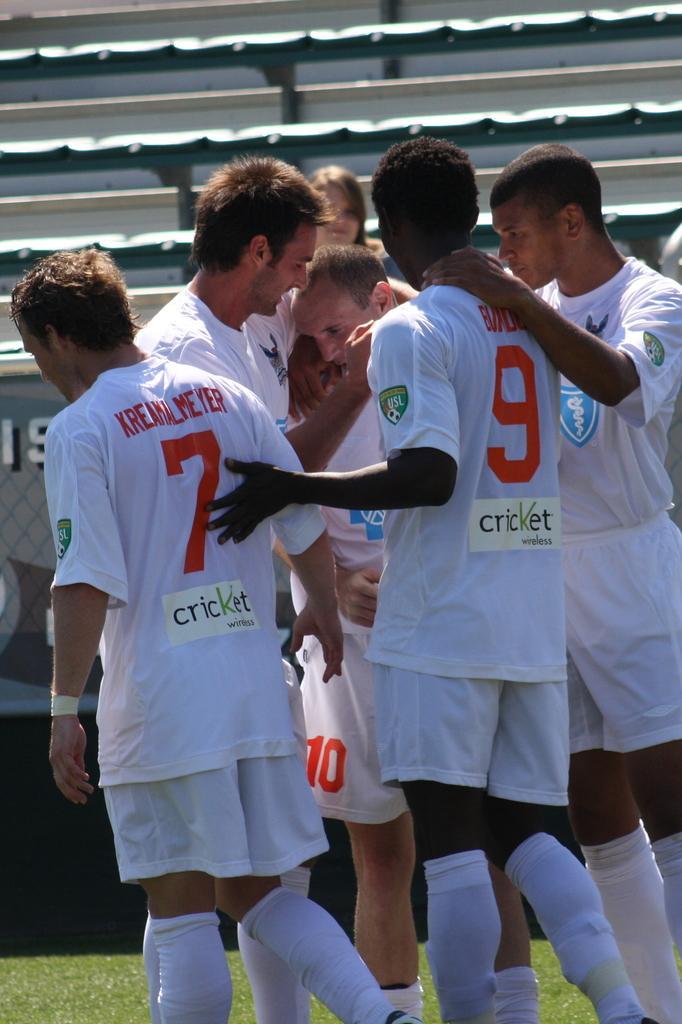How would you summarize this image in a sentence or two? There is a group of people standing and wearing a white color dress in the middle of this image. We can see there is a seating area in the background. 